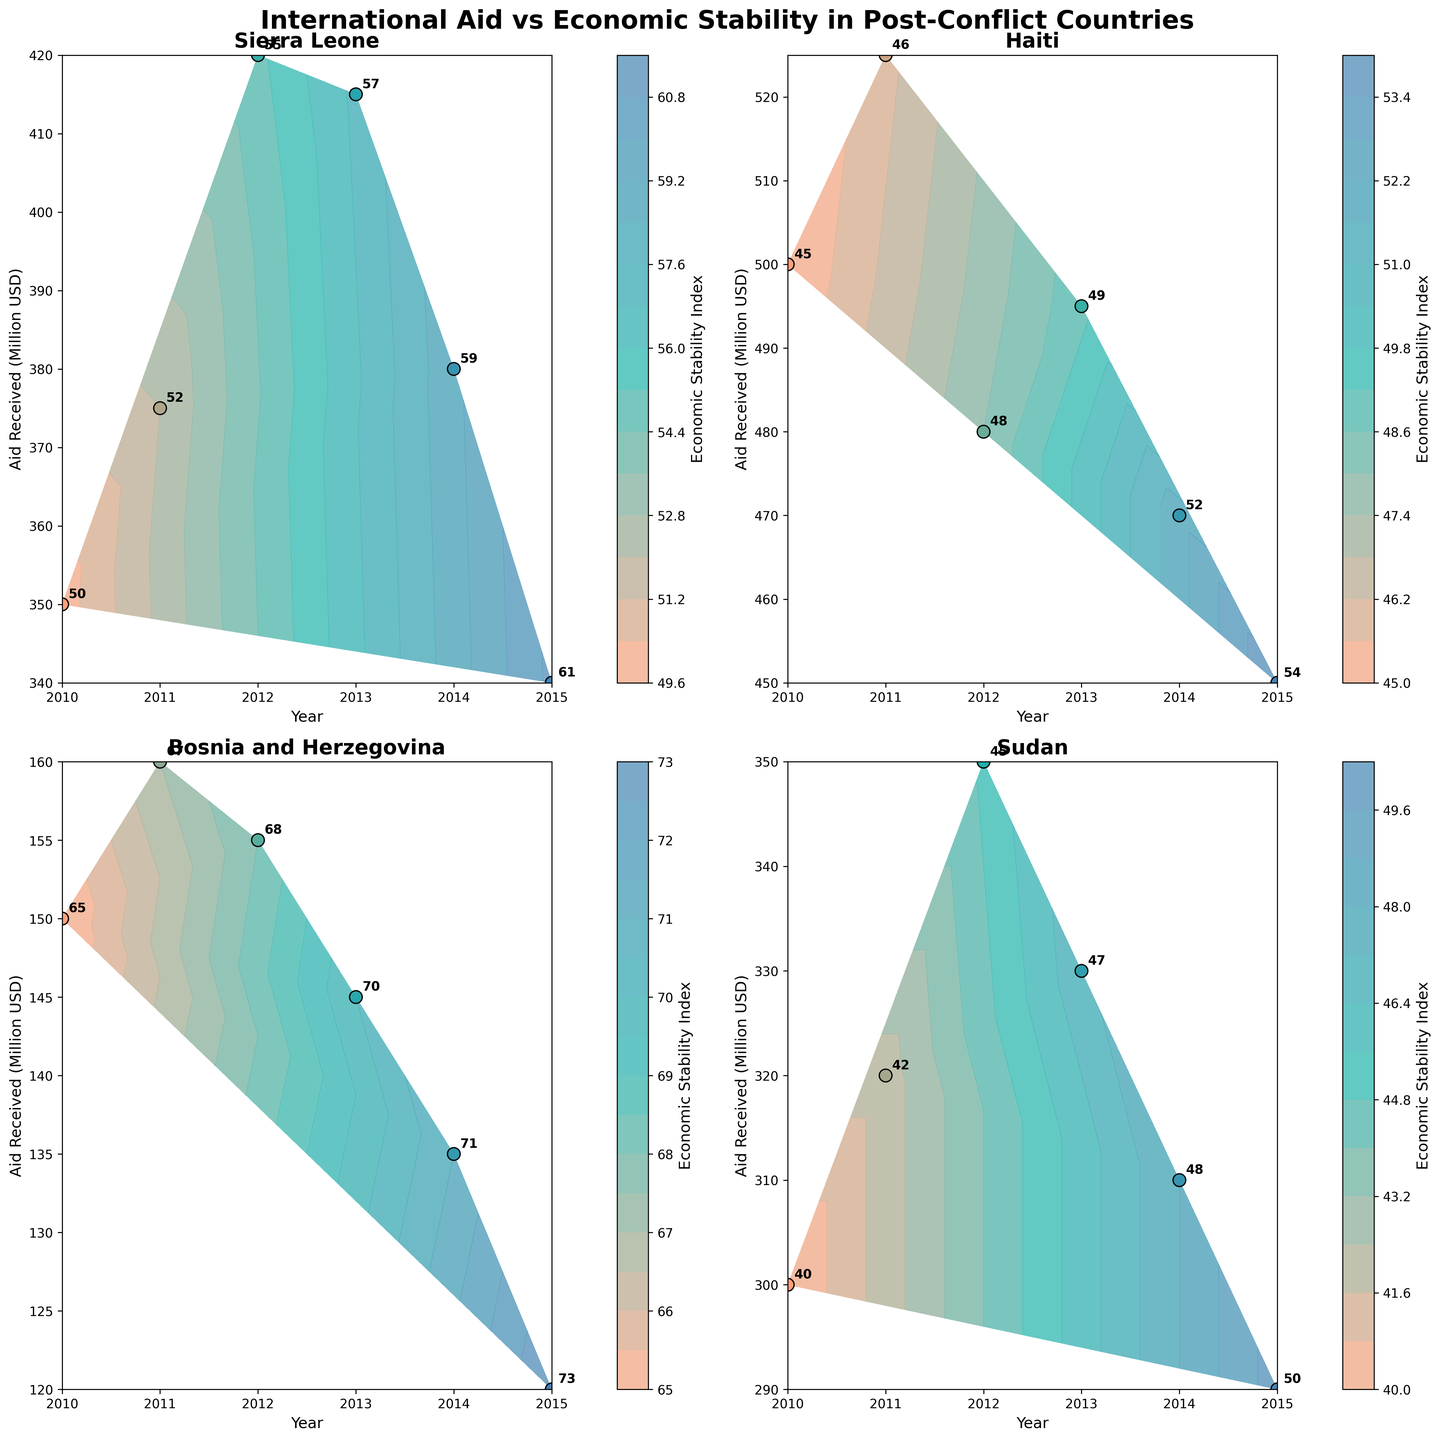Which country received the highest amount of aid in 2010? To find the country with the highest aid received in 2010, look at the corresponding subplots and check the 'Year' axis for 2010. Compare the 'Aid Received (Million USD)' values across the subplots.
Answer: Haiti What is the economic stability index of Bosnia and Herzegovina in 2015? Locate Bosnia and Herzegovina's subplot, find the data point corresponding to 2015 on the 'Year' axis, and check the annotated economic stability index value.
Answer: 73 Which country shows the greatest improvement in economic stability index from 2010 to 2015? Calculate the difference in the economic stability index between 2015 and 2010 for each country. Compare these differences to find the greatest. Sierra Leone: 61-50=11, Haiti: 54-45=9, Bosnia and Herzegovina: 73-65=8, Sudan: 50-40=10.
Answer: Sierra Leone How did the aid received by Sudan change from 2010 to 2015? Look at Sudan's subplot and check the 'Aid Received (Million USD)' values at the years 2010 and 2015.
Answer: Decreased Between which years did Haiti experience the highest increase in its economic stability index? Analyze Haiti's subplot to determine the change in economic stability index for each year pair and identify the pair with the highest increase. 2010 to 2011: 1, 2011 to 2012: 2, 2012 to 2013: 1, 2013 to 2014: 3, 2014 to 2015: 2.
Answer: 2013 to 2014 Which country had the most stable economic stability index over the years? Examine each subplot to observe variations in the economic stability index for each country. The country with the least variation is the most stable.
Answer: Bosnia and Herzegovina In which year did Sierra Leone receive the maximum aid? Analyze Sierra Leone’s subplot and check the year corresponding to the peak 'Aid Received (Million USD)' value.
Answer: 2012 How does the relationship between aid received and economic stability vary across the different regions? Observe the overall trend in each subplot between 'Aid Received (Million USD)' and 'Economic Stability Index'. Compare how they change in each region (West Africa, Caribbean, Europe, North-East Africa).
Answer: Varies What is the average aid received by Haiti from 2010 to 2015? Sum the 'Aid Received (Million USD)' values for each year for Haiti and divide by the number of years (6). (500 + 525 + 480 + 495 + 470 + 450) / 6 = 490.
Answer: 490 Which country had the highest economic stability index in any given year? Locate the highest annotated economic stability index value across all subplots and determine the corresponding country.
Answer: Bosnia and Herzegovina 